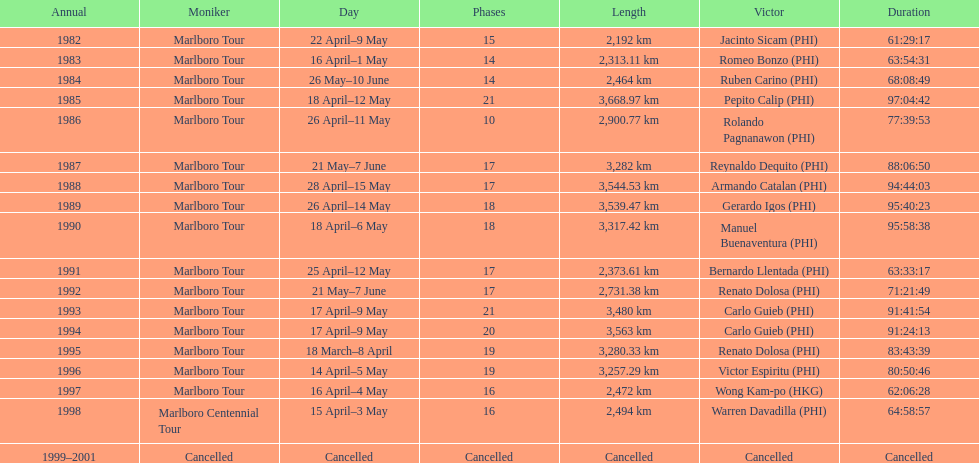What was the total number of winners before the tour was canceled? 17. 